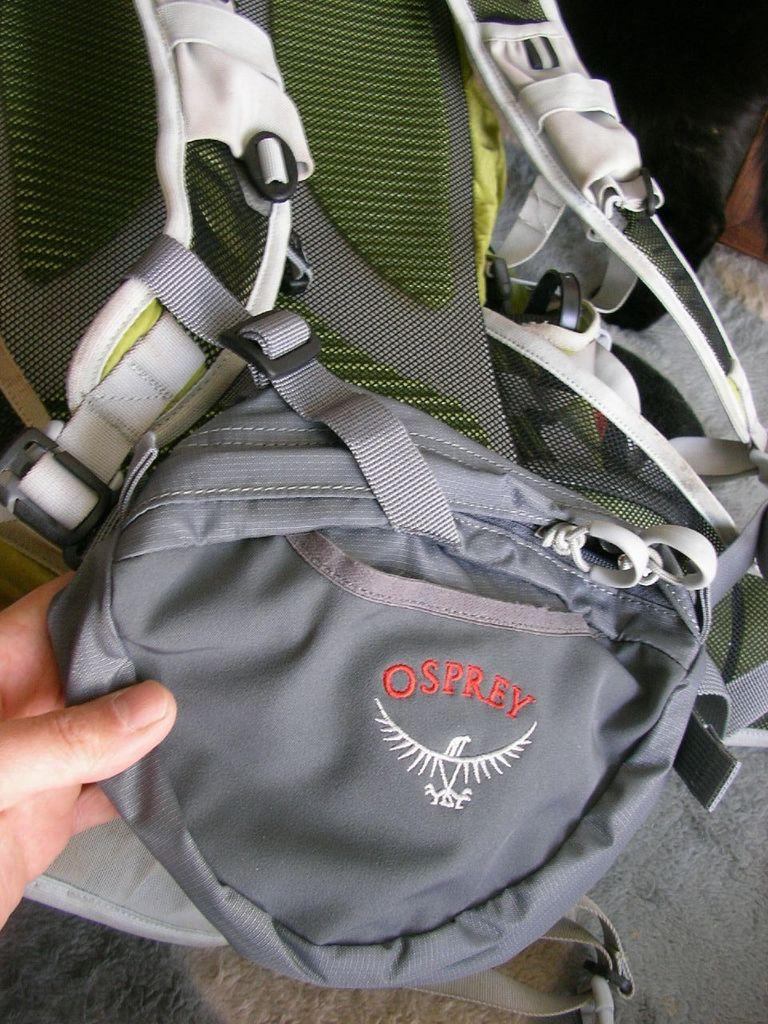What object is being held by a person's hand in the image? A: There is a bag in the image, and it is being held by a person's hand. Is there any fire visible in the image? No, there is no fire present in the image. Are there any boats in the image? No, there are no boats present in the image. 